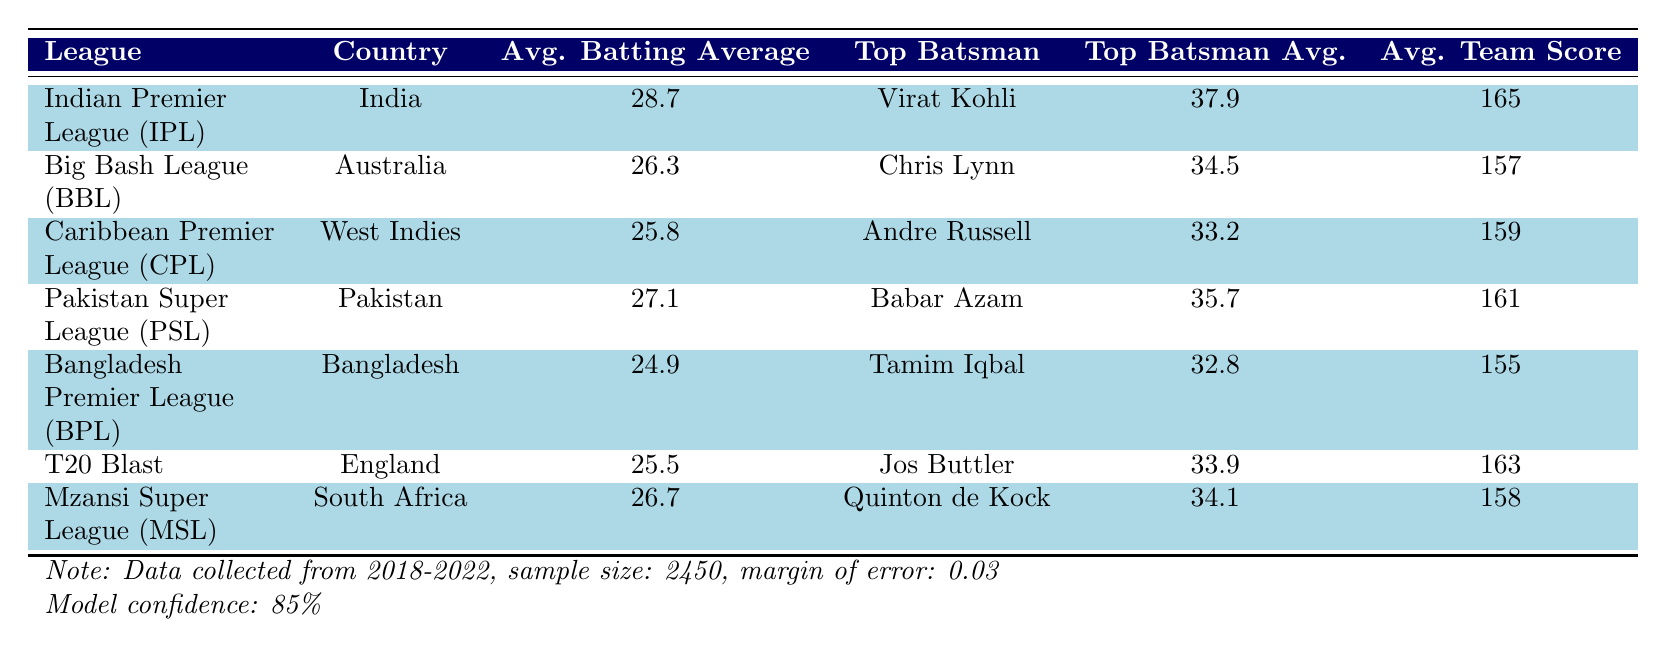What is the average batting average in the Indian Premier League (IPL)? The table lists the average batting average for the IPL as 28.7.
Answer: 28.7 Which league has the highest average team score? By reviewing the average team scores in the table, the IPL has the highest average team score at 165.
Answer: 165 How much higher is the average batting average in the PSL compared to the BPL? The average batting average of the PSL is 27.1, and that of the BPL is 24.9. The difference is 27.1 - 24.9 = 2.2.
Answer: 2.2 Is Babar Azam the top batsman in the Indian Premier League (IPL)? The table shows that the top batsman in the IPL is Virat Kohli, not Babar Azam. Therefore, the statement is false.
Answer: No How does Chris Lynn's batting average compare to Andre Russell's in the leagues? Chris Lynn has a batting average of 34.5 in the BBL, while Andre Russell has an average of 33.2 in the CPL. Chris Lynn's average is higher by 34.5 - 33.2 = 1.3.
Answer: 1.3 What is the total average batting average across all leagues listed? Summing the average batting averages: 28.7 (IPL) + 26.3 (BBL) + 25.8 (CPL) + 27.1 (PSL) + 24.9 (BPL) + 25.5 (T20 Blast) + 26.7 (MSL) gives us 28.7 + 26.3 + 25.8 + 27.1 + 24.9 + 25.5 + 26.7 = 184.0. Dividing by the number of leagues (7), the average is 184.0 / 7 = 26.29.
Answer: 26.29 Which batsman has the highest average and in which league do they play? Virat Kohli has the highest batting average of 37.9 and he plays in the Indian Premier League (IPL).
Answer: Virat Kohli in IPL Does the Mzansi Super League (MSL) have a higher average batting average than the Caribbean Premier League (CPL)? The average batting average for MSL is 26.7, and for CPL it is 25.8. Since 26.7 is greater than 25.8, the statement is true.
Answer: Yes 